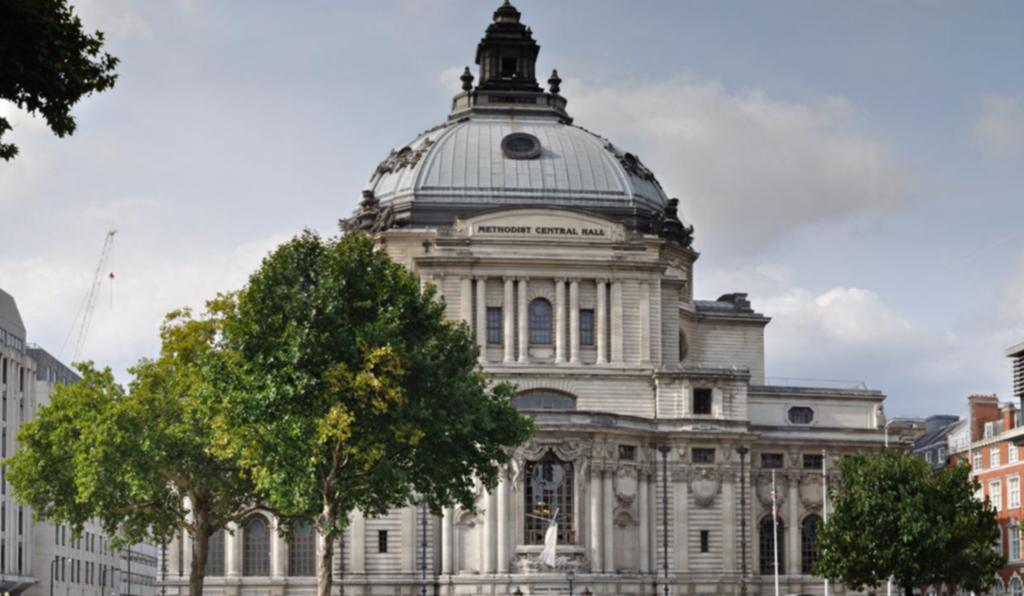What type of building is in the image? There is a palace in the image. What can be seen in front of the palace? Trees are present in front of the palace on either side. What is visible in the background of the image? The sky is visible in the image. What can be observed in the sky? Clouds are present in the sky. What type of bean is growing in the window of the palace in the image? There is no bean or window present in the image; it features a palace with trees and a sky with clouds. 